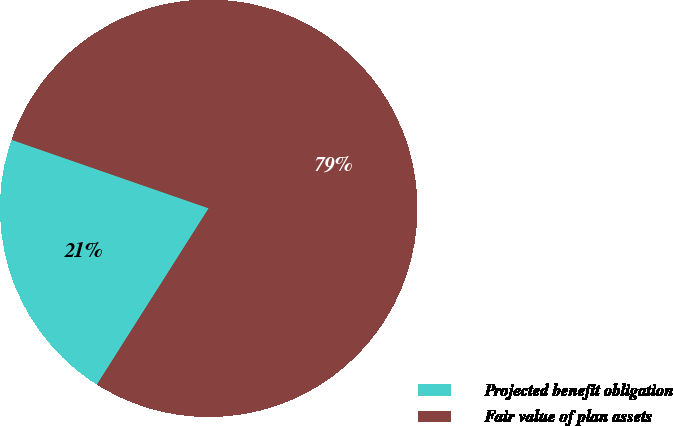<chart> <loc_0><loc_0><loc_500><loc_500><pie_chart><fcel>Projected benefit obligation<fcel>Fair value of plan assets<nl><fcel>21.33%<fcel>78.67%<nl></chart> 